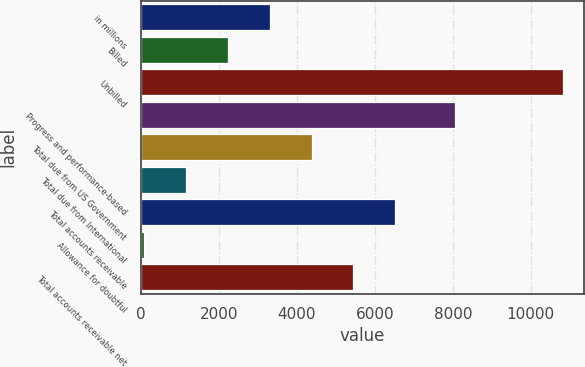Convert chart. <chart><loc_0><loc_0><loc_500><loc_500><bar_chart><fcel>in millions<fcel>Billed<fcel>Unbilled<fcel>Progress and performance-based<fcel>Total due from US Government<fcel>Total due from International<fcel>Total accounts receivable<fcel>Allowance for doubtful<fcel>Total accounts receivable net<nl><fcel>3300.7<fcel>2226.8<fcel>10818<fcel>8068<fcel>4374.6<fcel>1152.9<fcel>6522.4<fcel>79<fcel>5448.5<nl></chart> 